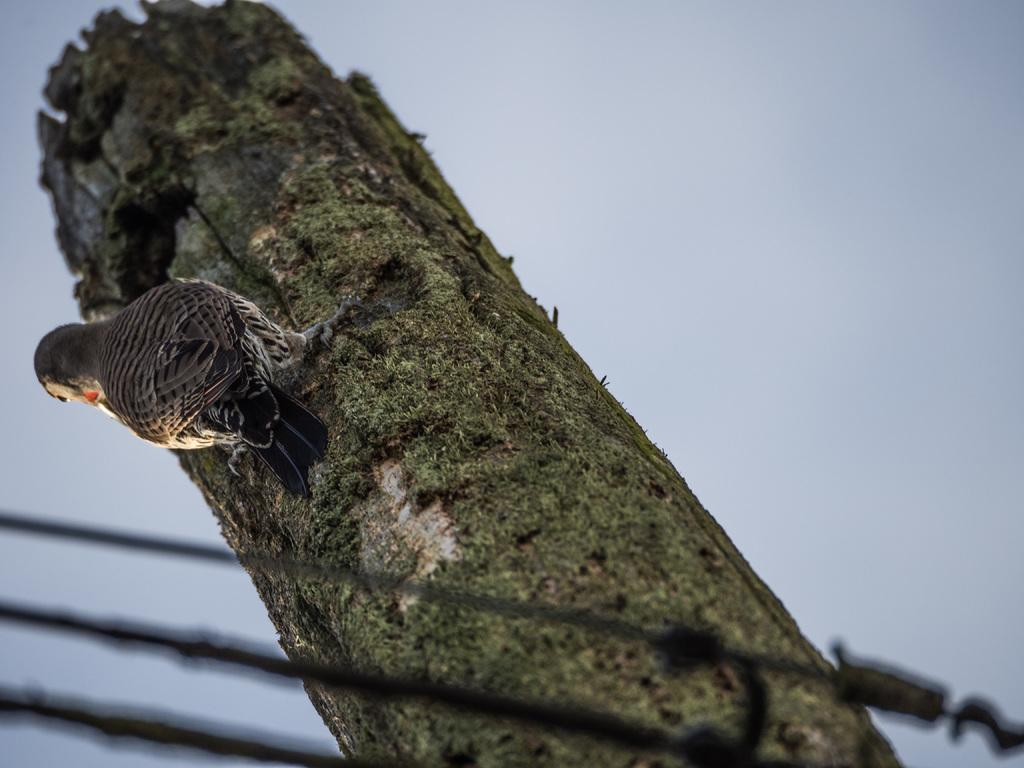What type of animal can be seen in the picture? There is a bird in the picture. What is the bird standing on? The bird is on a wooden object. What can be seen at the bottom of the picture? There are a few objects visible at the bottom of the picture. What is visible at the top of the picture? The sky is visible at the top of the picture. What type of wine is being served by the judge in the image? There is no judge or wine present in the image; it features a bird on a wooden object with a sky background. 